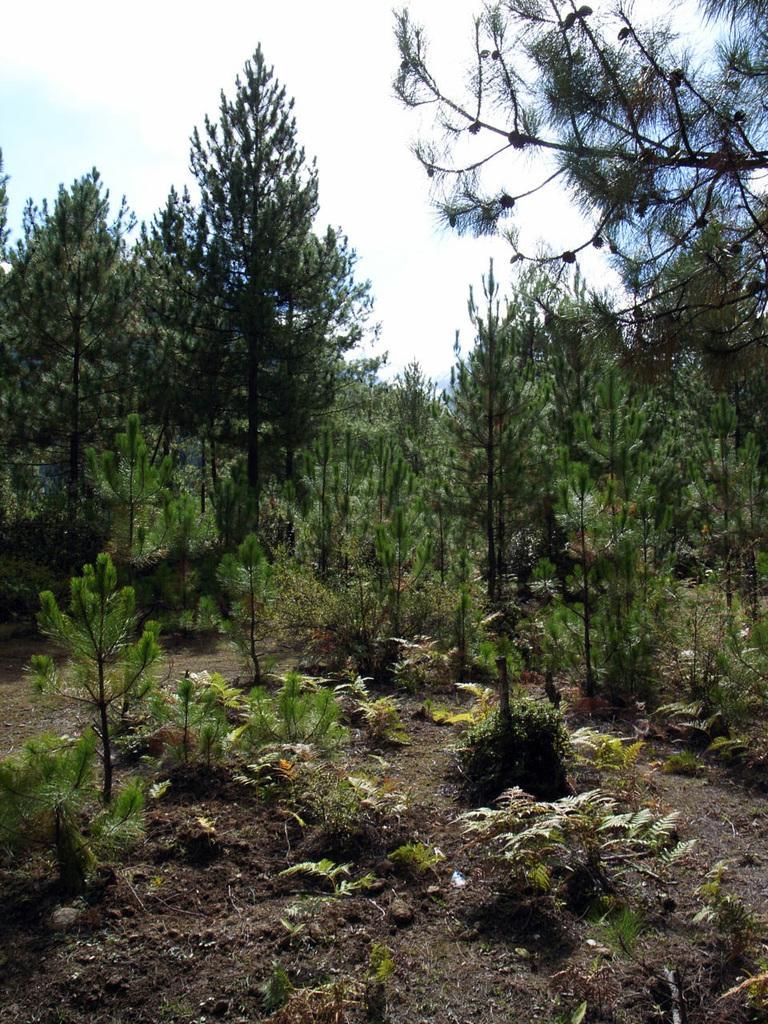Describe this image in one or two sentences. In this picture we can see trees, plants and we can see sky in the background. 